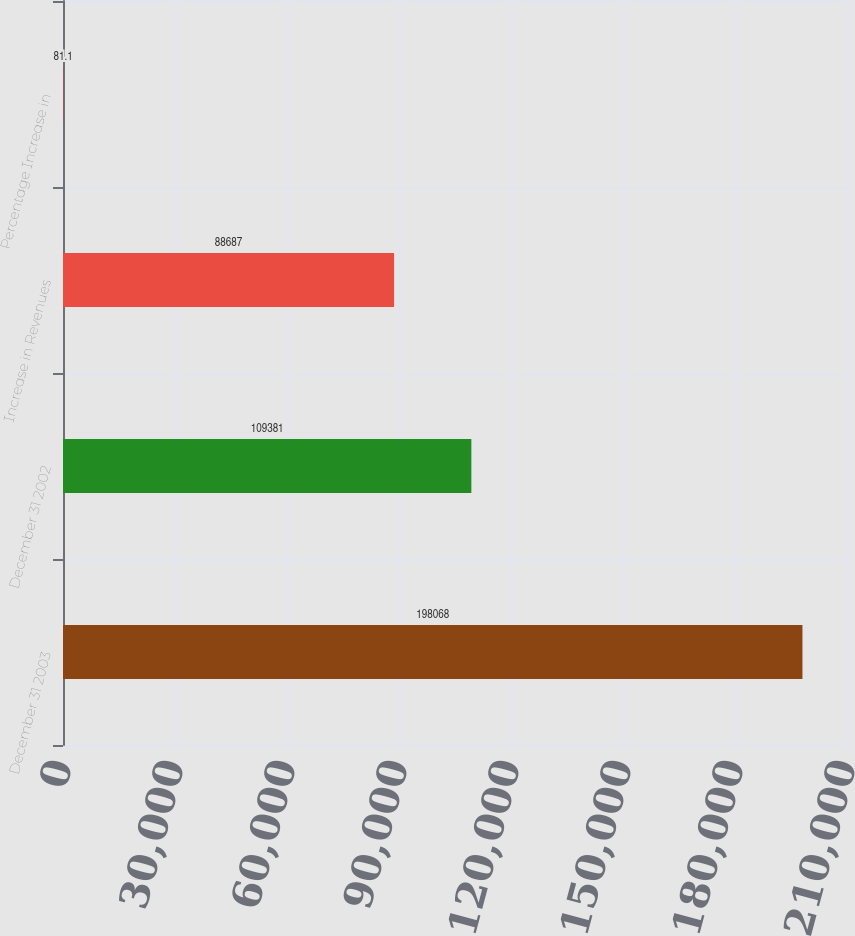Convert chart to OTSL. <chart><loc_0><loc_0><loc_500><loc_500><bar_chart><fcel>December 31 2003<fcel>December 31 2002<fcel>Increase in Revenues<fcel>Percentage Increase in<nl><fcel>198068<fcel>109381<fcel>88687<fcel>81.1<nl></chart> 